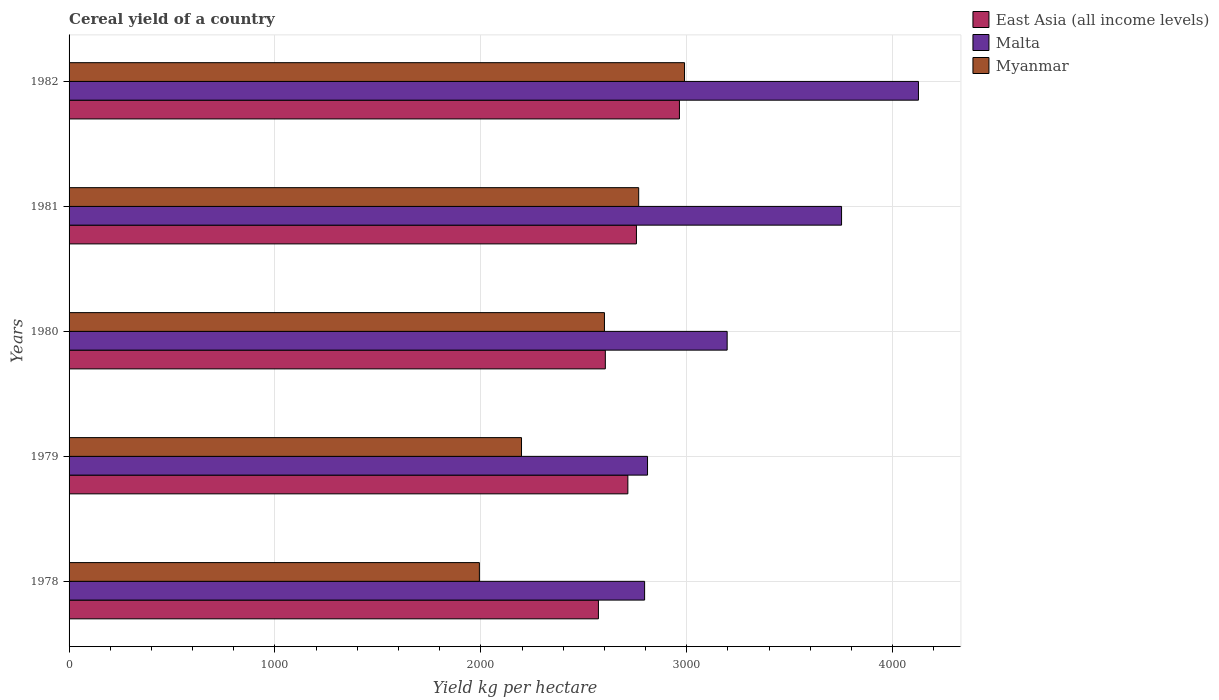How many different coloured bars are there?
Ensure brevity in your answer.  3. Are the number of bars per tick equal to the number of legend labels?
Make the answer very short. Yes. How many bars are there on the 2nd tick from the bottom?
Provide a short and direct response. 3. What is the label of the 3rd group of bars from the top?
Your response must be concise. 1980. In how many cases, is the number of bars for a given year not equal to the number of legend labels?
Make the answer very short. 0. What is the total cereal yield in Myanmar in 1982?
Keep it short and to the point. 2989.14. Across all years, what is the maximum total cereal yield in East Asia (all income levels)?
Make the answer very short. 2964.38. Across all years, what is the minimum total cereal yield in Myanmar?
Your answer should be very brief. 1992.81. In which year was the total cereal yield in Myanmar maximum?
Offer a very short reply. 1982. In which year was the total cereal yield in Malta minimum?
Give a very brief answer. 1978. What is the total total cereal yield in Myanmar in the graph?
Your answer should be very brief. 1.25e+04. What is the difference between the total cereal yield in Malta in 1979 and that in 1980?
Ensure brevity in your answer.  -386.71. What is the difference between the total cereal yield in Malta in 1981 and the total cereal yield in East Asia (all income levels) in 1979?
Your answer should be compact. 1037.91. What is the average total cereal yield in Myanmar per year?
Provide a short and direct response. 2509.19. In the year 1980, what is the difference between the total cereal yield in Malta and total cereal yield in East Asia (all income levels)?
Ensure brevity in your answer.  591.74. What is the ratio of the total cereal yield in Myanmar in 1980 to that in 1982?
Ensure brevity in your answer.  0.87. What is the difference between the highest and the second highest total cereal yield in East Asia (all income levels)?
Give a very brief answer. 208.84. What is the difference between the highest and the lowest total cereal yield in Malta?
Provide a succinct answer. 1330. In how many years, is the total cereal yield in East Asia (all income levels) greater than the average total cereal yield in East Asia (all income levels) taken over all years?
Ensure brevity in your answer.  2. Is the sum of the total cereal yield in East Asia (all income levels) in 1978 and 1982 greater than the maximum total cereal yield in Malta across all years?
Ensure brevity in your answer.  Yes. What does the 1st bar from the top in 1981 represents?
Your response must be concise. Myanmar. What does the 1st bar from the bottom in 1979 represents?
Offer a terse response. East Asia (all income levels). Are the values on the major ticks of X-axis written in scientific E-notation?
Ensure brevity in your answer.  No. Does the graph contain grids?
Make the answer very short. Yes. How many legend labels are there?
Make the answer very short. 3. How are the legend labels stacked?
Offer a terse response. Vertical. What is the title of the graph?
Provide a succinct answer. Cereal yield of a country. What is the label or title of the X-axis?
Your answer should be very brief. Yield kg per hectare. What is the label or title of the Y-axis?
Give a very brief answer. Years. What is the Yield kg per hectare in East Asia (all income levels) in 1978?
Your answer should be very brief. 2570.94. What is the Yield kg per hectare of Malta in 1978?
Offer a very short reply. 2795.26. What is the Yield kg per hectare in Myanmar in 1978?
Your answer should be very brief. 1992.81. What is the Yield kg per hectare of East Asia (all income levels) in 1979?
Make the answer very short. 2713.87. What is the Yield kg per hectare of Malta in 1979?
Keep it short and to the point. 2809.46. What is the Yield kg per hectare of Myanmar in 1979?
Keep it short and to the point. 2197.38. What is the Yield kg per hectare of East Asia (all income levels) in 1980?
Your answer should be compact. 2604.44. What is the Yield kg per hectare of Malta in 1980?
Your answer should be compact. 3196.18. What is the Yield kg per hectare of Myanmar in 1980?
Your answer should be compact. 2600.19. What is the Yield kg per hectare of East Asia (all income levels) in 1981?
Make the answer very short. 2755.54. What is the Yield kg per hectare of Malta in 1981?
Your response must be concise. 3751.78. What is the Yield kg per hectare of Myanmar in 1981?
Your answer should be compact. 2766.45. What is the Yield kg per hectare of East Asia (all income levels) in 1982?
Offer a terse response. 2964.38. What is the Yield kg per hectare in Malta in 1982?
Offer a terse response. 4125.26. What is the Yield kg per hectare of Myanmar in 1982?
Your answer should be compact. 2989.14. Across all years, what is the maximum Yield kg per hectare in East Asia (all income levels)?
Offer a terse response. 2964.38. Across all years, what is the maximum Yield kg per hectare of Malta?
Your answer should be very brief. 4125.26. Across all years, what is the maximum Yield kg per hectare in Myanmar?
Give a very brief answer. 2989.14. Across all years, what is the minimum Yield kg per hectare in East Asia (all income levels)?
Keep it short and to the point. 2570.94. Across all years, what is the minimum Yield kg per hectare of Malta?
Your answer should be very brief. 2795.26. Across all years, what is the minimum Yield kg per hectare in Myanmar?
Ensure brevity in your answer.  1992.81. What is the total Yield kg per hectare in East Asia (all income levels) in the graph?
Make the answer very short. 1.36e+04. What is the total Yield kg per hectare of Malta in the graph?
Offer a very short reply. 1.67e+04. What is the total Yield kg per hectare of Myanmar in the graph?
Ensure brevity in your answer.  1.25e+04. What is the difference between the Yield kg per hectare in East Asia (all income levels) in 1978 and that in 1979?
Ensure brevity in your answer.  -142.93. What is the difference between the Yield kg per hectare in Malta in 1978 and that in 1979?
Offer a terse response. -14.2. What is the difference between the Yield kg per hectare in Myanmar in 1978 and that in 1979?
Your response must be concise. -204.57. What is the difference between the Yield kg per hectare of East Asia (all income levels) in 1978 and that in 1980?
Provide a succinct answer. -33.5. What is the difference between the Yield kg per hectare of Malta in 1978 and that in 1980?
Make the answer very short. -400.92. What is the difference between the Yield kg per hectare of Myanmar in 1978 and that in 1980?
Offer a very short reply. -607.38. What is the difference between the Yield kg per hectare in East Asia (all income levels) in 1978 and that in 1981?
Offer a very short reply. -184.6. What is the difference between the Yield kg per hectare of Malta in 1978 and that in 1981?
Give a very brief answer. -956.52. What is the difference between the Yield kg per hectare in Myanmar in 1978 and that in 1981?
Give a very brief answer. -773.64. What is the difference between the Yield kg per hectare of East Asia (all income levels) in 1978 and that in 1982?
Keep it short and to the point. -393.45. What is the difference between the Yield kg per hectare in Malta in 1978 and that in 1982?
Offer a terse response. -1330. What is the difference between the Yield kg per hectare in Myanmar in 1978 and that in 1982?
Offer a very short reply. -996.33. What is the difference between the Yield kg per hectare of East Asia (all income levels) in 1979 and that in 1980?
Give a very brief answer. 109.43. What is the difference between the Yield kg per hectare in Malta in 1979 and that in 1980?
Make the answer very short. -386.71. What is the difference between the Yield kg per hectare in Myanmar in 1979 and that in 1980?
Ensure brevity in your answer.  -402.81. What is the difference between the Yield kg per hectare in East Asia (all income levels) in 1979 and that in 1981?
Give a very brief answer. -41.67. What is the difference between the Yield kg per hectare in Malta in 1979 and that in 1981?
Your answer should be very brief. -942.32. What is the difference between the Yield kg per hectare of Myanmar in 1979 and that in 1981?
Provide a succinct answer. -569.07. What is the difference between the Yield kg per hectare of East Asia (all income levels) in 1979 and that in 1982?
Provide a short and direct response. -250.51. What is the difference between the Yield kg per hectare in Malta in 1979 and that in 1982?
Your answer should be compact. -1315.8. What is the difference between the Yield kg per hectare in Myanmar in 1979 and that in 1982?
Ensure brevity in your answer.  -791.76. What is the difference between the Yield kg per hectare of East Asia (all income levels) in 1980 and that in 1981?
Provide a succinct answer. -151.1. What is the difference between the Yield kg per hectare of Malta in 1980 and that in 1981?
Keep it short and to the point. -555.61. What is the difference between the Yield kg per hectare in Myanmar in 1980 and that in 1981?
Provide a succinct answer. -166.26. What is the difference between the Yield kg per hectare in East Asia (all income levels) in 1980 and that in 1982?
Keep it short and to the point. -359.94. What is the difference between the Yield kg per hectare of Malta in 1980 and that in 1982?
Provide a short and direct response. -929.09. What is the difference between the Yield kg per hectare in Myanmar in 1980 and that in 1982?
Offer a very short reply. -388.95. What is the difference between the Yield kg per hectare of East Asia (all income levels) in 1981 and that in 1982?
Offer a very short reply. -208.84. What is the difference between the Yield kg per hectare in Malta in 1981 and that in 1982?
Provide a short and direct response. -373.48. What is the difference between the Yield kg per hectare of Myanmar in 1981 and that in 1982?
Your answer should be compact. -222.69. What is the difference between the Yield kg per hectare in East Asia (all income levels) in 1978 and the Yield kg per hectare in Malta in 1979?
Provide a short and direct response. -238.52. What is the difference between the Yield kg per hectare in East Asia (all income levels) in 1978 and the Yield kg per hectare in Myanmar in 1979?
Keep it short and to the point. 373.56. What is the difference between the Yield kg per hectare of Malta in 1978 and the Yield kg per hectare of Myanmar in 1979?
Your answer should be very brief. 597.88. What is the difference between the Yield kg per hectare of East Asia (all income levels) in 1978 and the Yield kg per hectare of Malta in 1980?
Offer a terse response. -625.24. What is the difference between the Yield kg per hectare in East Asia (all income levels) in 1978 and the Yield kg per hectare in Myanmar in 1980?
Give a very brief answer. -29.25. What is the difference between the Yield kg per hectare in Malta in 1978 and the Yield kg per hectare in Myanmar in 1980?
Offer a terse response. 195.07. What is the difference between the Yield kg per hectare of East Asia (all income levels) in 1978 and the Yield kg per hectare of Malta in 1981?
Your answer should be compact. -1180.85. What is the difference between the Yield kg per hectare of East Asia (all income levels) in 1978 and the Yield kg per hectare of Myanmar in 1981?
Keep it short and to the point. -195.51. What is the difference between the Yield kg per hectare of Malta in 1978 and the Yield kg per hectare of Myanmar in 1981?
Keep it short and to the point. 28.81. What is the difference between the Yield kg per hectare of East Asia (all income levels) in 1978 and the Yield kg per hectare of Malta in 1982?
Make the answer very short. -1554.32. What is the difference between the Yield kg per hectare of East Asia (all income levels) in 1978 and the Yield kg per hectare of Myanmar in 1982?
Your answer should be very brief. -418.2. What is the difference between the Yield kg per hectare of Malta in 1978 and the Yield kg per hectare of Myanmar in 1982?
Keep it short and to the point. -193.88. What is the difference between the Yield kg per hectare of East Asia (all income levels) in 1979 and the Yield kg per hectare of Malta in 1980?
Keep it short and to the point. -482.3. What is the difference between the Yield kg per hectare in East Asia (all income levels) in 1979 and the Yield kg per hectare in Myanmar in 1980?
Provide a succinct answer. 113.68. What is the difference between the Yield kg per hectare in Malta in 1979 and the Yield kg per hectare in Myanmar in 1980?
Ensure brevity in your answer.  209.27. What is the difference between the Yield kg per hectare of East Asia (all income levels) in 1979 and the Yield kg per hectare of Malta in 1981?
Your answer should be compact. -1037.91. What is the difference between the Yield kg per hectare of East Asia (all income levels) in 1979 and the Yield kg per hectare of Myanmar in 1981?
Offer a very short reply. -52.58. What is the difference between the Yield kg per hectare in Malta in 1979 and the Yield kg per hectare in Myanmar in 1981?
Provide a short and direct response. 43.01. What is the difference between the Yield kg per hectare in East Asia (all income levels) in 1979 and the Yield kg per hectare in Malta in 1982?
Provide a succinct answer. -1411.39. What is the difference between the Yield kg per hectare in East Asia (all income levels) in 1979 and the Yield kg per hectare in Myanmar in 1982?
Make the answer very short. -275.27. What is the difference between the Yield kg per hectare in Malta in 1979 and the Yield kg per hectare in Myanmar in 1982?
Your response must be concise. -179.68. What is the difference between the Yield kg per hectare of East Asia (all income levels) in 1980 and the Yield kg per hectare of Malta in 1981?
Make the answer very short. -1147.35. What is the difference between the Yield kg per hectare in East Asia (all income levels) in 1980 and the Yield kg per hectare in Myanmar in 1981?
Your answer should be compact. -162.01. What is the difference between the Yield kg per hectare in Malta in 1980 and the Yield kg per hectare in Myanmar in 1981?
Provide a short and direct response. 429.72. What is the difference between the Yield kg per hectare of East Asia (all income levels) in 1980 and the Yield kg per hectare of Malta in 1982?
Provide a short and direct response. -1520.82. What is the difference between the Yield kg per hectare in East Asia (all income levels) in 1980 and the Yield kg per hectare in Myanmar in 1982?
Provide a succinct answer. -384.7. What is the difference between the Yield kg per hectare of Malta in 1980 and the Yield kg per hectare of Myanmar in 1982?
Make the answer very short. 207.04. What is the difference between the Yield kg per hectare in East Asia (all income levels) in 1981 and the Yield kg per hectare in Malta in 1982?
Your answer should be very brief. -1369.72. What is the difference between the Yield kg per hectare of East Asia (all income levels) in 1981 and the Yield kg per hectare of Myanmar in 1982?
Offer a very short reply. -233.6. What is the difference between the Yield kg per hectare of Malta in 1981 and the Yield kg per hectare of Myanmar in 1982?
Ensure brevity in your answer.  762.65. What is the average Yield kg per hectare of East Asia (all income levels) per year?
Keep it short and to the point. 2721.83. What is the average Yield kg per hectare in Malta per year?
Offer a terse response. 3335.59. What is the average Yield kg per hectare in Myanmar per year?
Your answer should be compact. 2509.19. In the year 1978, what is the difference between the Yield kg per hectare in East Asia (all income levels) and Yield kg per hectare in Malta?
Offer a very short reply. -224.32. In the year 1978, what is the difference between the Yield kg per hectare of East Asia (all income levels) and Yield kg per hectare of Myanmar?
Give a very brief answer. 578.13. In the year 1978, what is the difference between the Yield kg per hectare in Malta and Yield kg per hectare in Myanmar?
Provide a short and direct response. 802.45. In the year 1979, what is the difference between the Yield kg per hectare in East Asia (all income levels) and Yield kg per hectare in Malta?
Provide a short and direct response. -95.59. In the year 1979, what is the difference between the Yield kg per hectare of East Asia (all income levels) and Yield kg per hectare of Myanmar?
Keep it short and to the point. 516.49. In the year 1979, what is the difference between the Yield kg per hectare in Malta and Yield kg per hectare in Myanmar?
Your response must be concise. 612.08. In the year 1980, what is the difference between the Yield kg per hectare in East Asia (all income levels) and Yield kg per hectare in Malta?
Your response must be concise. -591.74. In the year 1980, what is the difference between the Yield kg per hectare in East Asia (all income levels) and Yield kg per hectare in Myanmar?
Ensure brevity in your answer.  4.25. In the year 1980, what is the difference between the Yield kg per hectare in Malta and Yield kg per hectare in Myanmar?
Provide a short and direct response. 595.99. In the year 1981, what is the difference between the Yield kg per hectare of East Asia (all income levels) and Yield kg per hectare of Malta?
Keep it short and to the point. -996.24. In the year 1981, what is the difference between the Yield kg per hectare of East Asia (all income levels) and Yield kg per hectare of Myanmar?
Your response must be concise. -10.91. In the year 1981, what is the difference between the Yield kg per hectare of Malta and Yield kg per hectare of Myanmar?
Provide a short and direct response. 985.33. In the year 1982, what is the difference between the Yield kg per hectare in East Asia (all income levels) and Yield kg per hectare in Malta?
Give a very brief answer. -1160.88. In the year 1982, what is the difference between the Yield kg per hectare in East Asia (all income levels) and Yield kg per hectare in Myanmar?
Offer a terse response. -24.75. In the year 1982, what is the difference between the Yield kg per hectare of Malta and Yield kg per hectare of Myanmar?
Offer a terse response. 1136.12. What is the ratio of the Yield kg per hectare in East Asia (all income levels) in 1978 to that in 1979?
Your answer should be very brief. 0.95. What is the ratio of the Yield kg per hectare of Malta in 1978 to that in 1979?
Offer a terse response. 0.99. What is the ratio of the Yield kg per hectare in Myanmar in 1978 to that in 1979?
Offer a terse response. 0.91. What is the ratio of the Yield kg per hectare in East Asia (all income levels) in 1978 to that in 1980?
Keep it short and to the point. 0.99. What is the ratio of the Yield kg per hectare of Malta in 1978 to that in 1980?
Your response must be concise. 0.87. What is the ratio of the Yield kg per hectare in Myanmar in 1978 to that in 1980?
Give a very brief answer. 0.77. What is the ratio of the Yield kg per hectare in East Asia (all income levels) in 1978 to that in 1981?
Offer a very short reply. 0.93. What is the ratio of the Yield kg per hectare of Malta in 1978 to that in 1981?
Your answer should be compact. 0.74. What is the ratio of the Yield kg per hectare in Myanmar in 1978 to that in 1981?
Your answer should be compact. 0.72. What is the ratio of the Yield kg per hectare of East Asia (all income levels) in 1978 to that in 1982?
Your response must be concise. 0.87. What is the ratio of the Yield kg per hectare in Malta in 1978 to that in 1982?
Offer a terse response. 0.68. What is the ratio of the Yield kg per hectare of East Asia (all income levels) in 1979 to that in 1980?
Your answer should be compact. 1.04. What is the ratio of the Yield kg per hectare in Malta in 1979 to that in 1980?
Your answer should be compact. 0.88. What is the ratio of the Yield kg per hectare in Myanmar in 1979 to that in 1980?
Ensure brevity in your answer.  0.85. What is the ratio of the Yield kg per hectare in East Asia (all income levels) in 1979 to that in 1981?
Your answer should be compact. 0.98. What is the ratio of the Yield kg per hectare in Malta in 1979 to that in 1981?
Offer a terse response. 0.75. What is the ratio of the Yield kg per hectare of Myanmar in 1979 to that in 1981?
Offer a terse response. 0.79. What is the ratio of the Yield kg per hectare of East Asia (all income levels) in 1979 to that in 1982?
Your response must be concise. 0.92. What is the ratio of the Yield kg per hectare in Malta in 1979 to that in 1982?
Offer a terse response. 0.68. What is the ratio of the Yield kg per hectare of Myanmar in 1979 to that in 1982?
Give a very brief answer. 0.74. What is the ratio of the Yield kg per hectare in East Asia (all income levels) in 1980 to that in 1981?
Ensure brevity in your answer.  0.95. What is the ratio of the Yield kg per hectare in Malta in 1980 to that in 1981?
Provide a succinct answer. 0.85. What is the ratio of the Yield kg per hectare in Myanmar in 1980 to that in 1981?
Provide a succinct answer. 0.94. What is the ratio of the Yield kg per hectare of East Asia (all income levels) in 1980 to that in 1982?
Keep it short and to the point. 0.88. What is the ratio of the Yield kg per hectare of Malta in 1980 to that in 1982?
Offer a very short reply. 0.77. What is the ratio of the Yield kg per hectare of Myanmar in 1980 to that in 1982?
Keep it short and to the point. 0.87. What is the ratio of the Yield kg per hectare in East Asia (all income levels) in 1981 to that in 1982?
Your answer should be very brief. 0.93. What is the ratio of the Yield kg per hectare of Malta in 1981 to that in 1982?
Your response must be concise. 0.91. What is the ratio of the Yield kg per hectare in Myanmar in 1981 to that in 1982?
Your answer should be very brief. 0.93. What is the difference between the highest and the second highest Yield kg per hectare in East Asia (all income levels)?
Your answer should be very brief. 208.84. What is the difference between the highest and the second highest Yield kg per hectare of Malta?
Your response must be concise. 373.48. What is the difference between the highest and the second highest Yield kg per hectare in Myanmar?
Give a very brief answer. 222.69. What is the difference between the highest and the lowest Yield kg per hectare in East Asia (all income levels)?
Your answer should be very brief. 393.45. What is the difference between the highest and the lowest Yield kg per hectare in Malta?
Provide a short and direct response. 1330. What is the difference between the highest and the lowest Yield kg per hectare of Myanmar?
Make the answer very short. 996.33. 